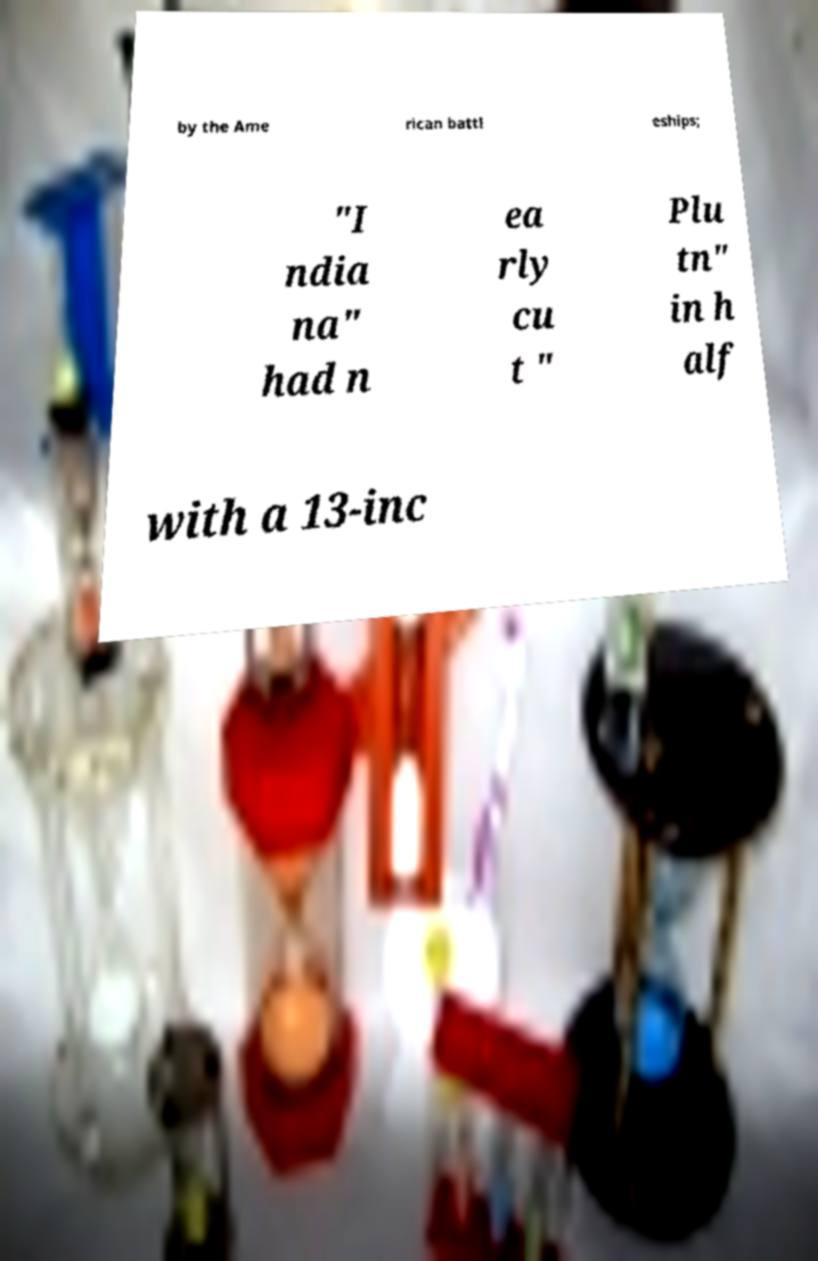Could you assist in decoding the text presented in this image and type it out clearly? by the Ame rican battl eships; "I ndia na" had n ea rly cu t " Plu tn" in h alf with a 13-inc 